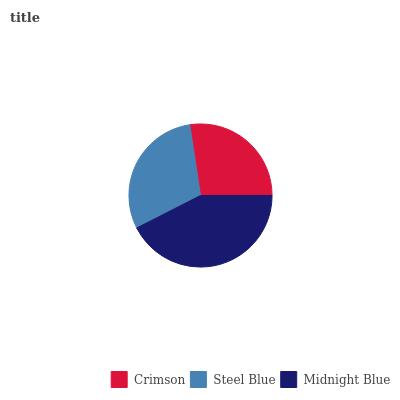Is Crimson the minimum?
Answer yes or no. Yes. Is Midnight Blue the maximum?
Answer yes or no. Yes. Is Steel Blue the minimum?
Answer yes or no. No. Is Steel Blue the maximum?
Answer yes or no. No. Is Steel Blue greater than Crimson?
Answer yes or no. Yes. Is Crimson less than Steel Blue?
Answer yes or no. Yes. Is Crimson greater than Steel Blue?
Answer yes or no. No. Is Steel Blue less than Crimson?
Answer yes or no. No. Is Steel Blue the high median?
Answer yes or no. Yes. Is Steel Blue the low median?
Answer yes or no. Yes. Is Crimson the high median?
Answer yes or no. No. Is Crimson the low median?
Answer yes or no. No. 